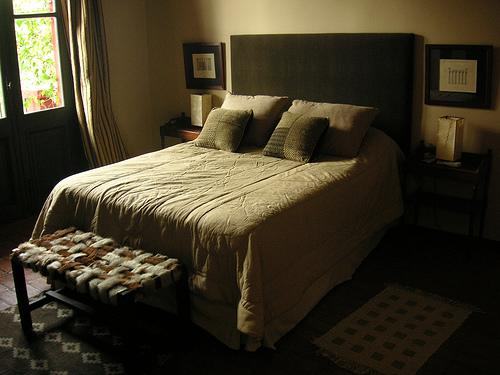What kind of pattern can be seen on the tan and white rug in front of the bed? The tan and white rug in front of the bed has a distinctive white diamond pattern. How many pillows are on the bed and what are their colors? There are four pillows on the bed, featuring a mix of green and tan colors. Count the total number of lamps and give a brief description of their shades. There are two lamps in the image; both have box-shaped shades, one shade is light brown, while the other one is short and rectangular. What is the view through the glass pane of the double doors? Through the glass pane, we can see green plant leaves and a red railing outside. What piece of furniture is located at the foot of the bed and what are its colors? A brown and white bench is located at the foot of the bed, featuring thick woven strips in its design. Describe the picture hanging on the wall and its aspect. The picture hanging on the wall is a framed image with lines in a square frame, located near the headboard of the bed. What type of room is displayed in the image and what is its general aesthetic? The image shows a neat and symmetrical bedroom with a green headboard, bedspread, and pillows, brown and white furniture, and a striped curtain by the window. Describe the curtains hanging near the window in the image. The curtains are long, striped, and tan in color, hanging by the window. Identify the two types of rugs found in the image and their patterns. There's a tan and white rug with a white diamond pattern and a white and grey rug with a checked pattern featuring thick woven strips. Provide a brief description of the headboard of the bed and its color. The headboard of the bed is green, made of fabric, and features a rectangular design. 